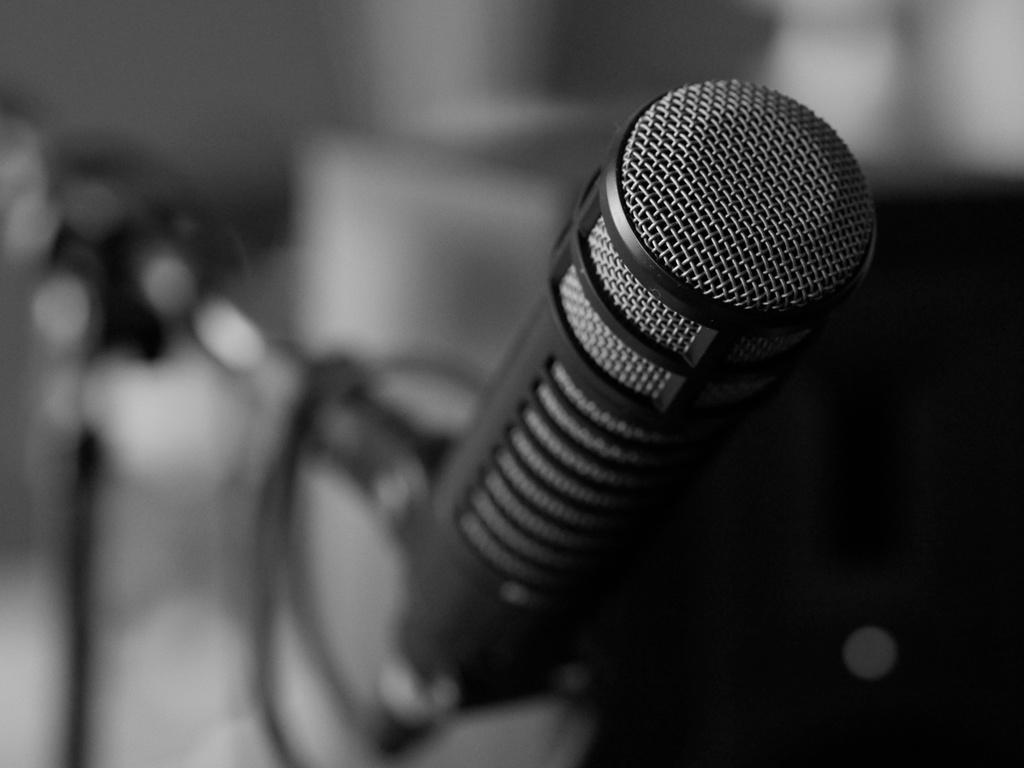What is the color scheme of the image? The image is black and white. What object can be seen in the image? There is a microphone (mic) in the image. Can you describe the background of the image? The background of the image is blurred. How many buttons are on the cup in the image? There is no cup present in the image, and therefore no buttons can be found on it. 